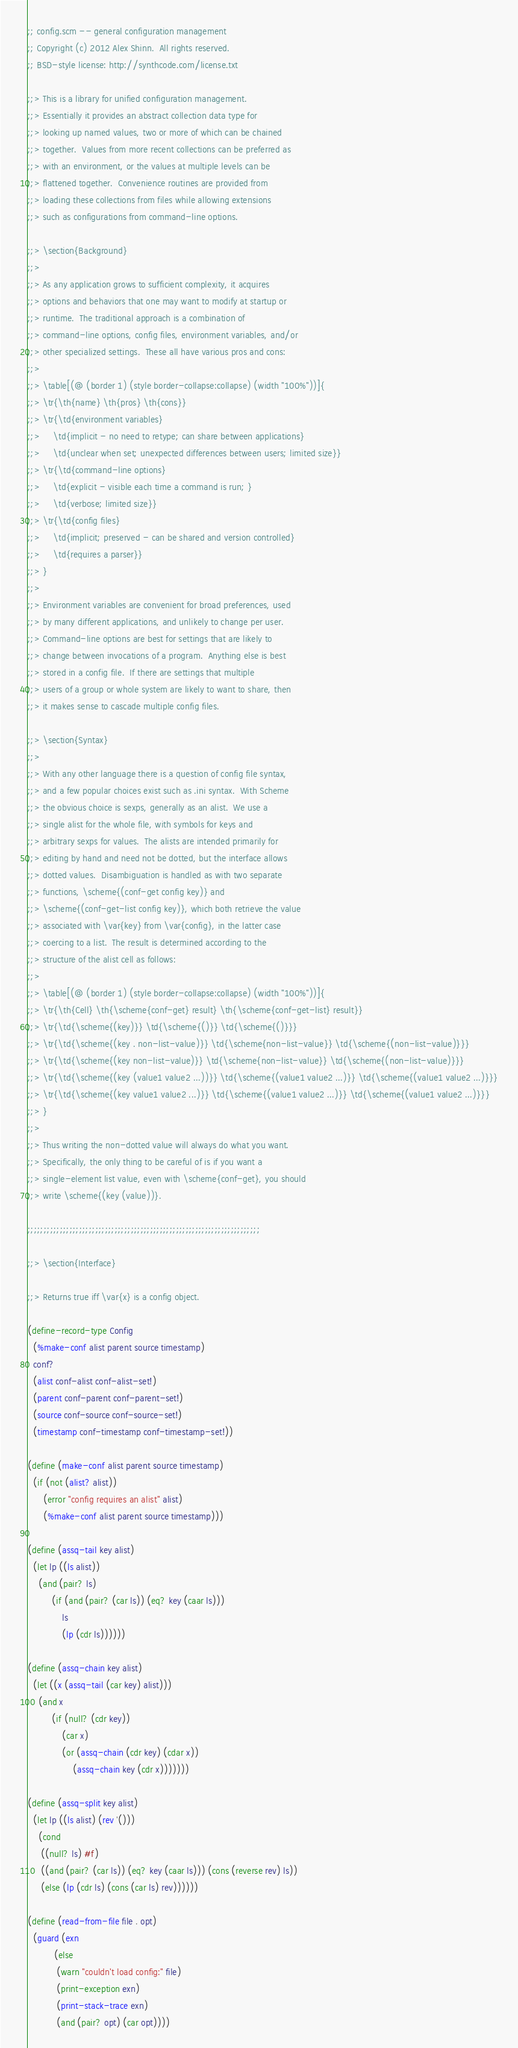Convert code to text. <code><loc_0><loc_0><loc_500><loc_500><_Scheme_>;; config.scm -- general configuration management
;; Copyright (c) 2012 Alex Shinn.  All rights reserved.
;; BSD-style license: http://synthcode.com/license.txt

;;> This is a library for unified configuration management.
;;> Essentially it provides an abstract collection data type for
;;> looking up named values, two or more of which can be chained
;;> together.  Values from more recent collections can be preferred as
;;> with an environment, or the values at multiple levels can be
;;> flattened together.  Convenience routines are provided from
;;> loading these collections from files while allowing extensions
;;> such as configurations from command-line options.

;;> \section{Background}
;;>
;;> As any application grows to sufficient complexity, it acquires
;;> options and behaviors that one may want to modify at startup or
;;> runtime.  The traditional approach is a combination of
;;> command-line options, config files, environment variables, and/or
;;> other specialized settings.  These all have various pros and cons:
;;>
;;> \table[(@ (border 1) (style border-collapse:collapse) (width "100%"))]{
;;> \tr{\th{name} \th{pros} \th{cons}}
;;> \tr{\td{environment variables}
;;>     \td{implicit - no need to retype; can share between applications}
;;>     \td{unclear when set; unexpected differences between users; limited size}}
;;> \tr{\td{command-line options}
;;>     \td{explicit - visible each time a command is run; }
;;>     \td{verbose; limited size}}
;;> \tr{\td{config files}
;;>     \td{implicit; preserved - can be shared and version controlled}
;;>     \td{requires a parser}}
;;> }
;;>
;;> Environment variables are convenient for broad preferences, used
;;> by many different applications, and unlikely to change per user.
;;> Command-line options are best for settings that are likely to
;;> change between invocations of a program.  Anything else is best
;;> stored in a config file.  If there are settings that multiple
;;> users of a group or whole system are likely to want to share, then
;;> it makes sense to cascade multiple config files.

;;> \section{Syntax}
;;>
;;> With any other language there is a question of config file syntax,
;;> and a few popular choices exist such as .ini syntax.  With Scheme
;;> the obvious choice is sexps, generally as an alist.  We use a
;;> single alist for the whole file, with symbols for keys and
;;> arbitrary sexps for values.  The alists are intended primarily for
;;> editing by hand and need not be dotted, but the interface allows
;;> dotted values.  Disambiguation is handled as with two separate
;;> functions, \scheme{(conf-get config key)} and
;;> \scheme{(conf-get-list config key)}, which both retrieve the value
;;> associated with \var{key} from \var{config}, in the latter case
;;> coercing to a list.  The result is determined according to the
;;> structure of the alist cell as follows:
;;>
;;> \table[(@ (border 1) (style border-collapse:collapse) (width "100%"))]{
;;> \tr{\th{Cell} \th{\scheme{conf-get} result} \th{\scheme{conf-get-list} result}}
;;> \tr{\td{\scheme{(key)}} \td{\scheme{()}} \td{\scheme{()}}}
;;> \tr{\td{\scheme{(key . non-list-value)}} \td{\scheme{non-list-value}} \td{\scheme{(non-list-value)}}}
;;> \tr{\td{\scheme{(key non-list-value)}} \td{\scheme{non-list-value}} \td{\scheme{(non-list-value)}}}
;;> \tr{\td{\scheme{(key (value1 value2 ...))}} \td{\scheme{(value1 value2 ...)}} \td{\scheme{(value1 value2 ...)}}}
;;> \tr{\td{\scheme{(key value1 value2 ...)}} \td{\scheme{(value1 value2 ...)}} \td{\scheme{(value1 value2 ...)}}}
;;> }
;;>
;;> Thus writing the non-dotted value will always do what you want.
;;> Specifically, the only thing to be careful of is if you want a
;;> single-element list value, even with \scheme{conf-get}, you should
;;> write \scheme{(key (value))}.

;;;;;;;;;;;;;;;;;;;;;;;;;;;;;;;;;;;;;;;;;;;;;;;;;;;;;;;;;;;;;;;;;;;;;;;;

;;> \section{Interface}

;;> Returns true iff \var{x} is a config object.

(define-record-type Config
  (%make-conf alist parent source timestamp)
  conf?
  (alist conf-alist conf-alist-set!)
  (parent conf-parent conf-parent-set!)
  (source conf-source conf-source-set!)
  (timestamp conf-timestamp conf-timestamp-set!))

(define (make-conf alist parent source timestamp)
  (if (not (alist? alist))
      (error "config requires an alist" alist)
      (%make-conf alist parent source timestamp)))

(define (assq-tail key alist)
  (let lp ((ls alist))
    (and (pair? ls)
         (if (and (pair? (car ls)) (eq? key (caar ls)))
             ls
             (lp (cdr ls))))))

(define (assq-chain key alist)
  (let ((x (assq-tail (car key) alist)))
    (and x
         (if (null? (cdr key))
             (car x)
             (or (assq-chain (cdr key) (cdar x))
                 (assq-chain key (cdr x)))))))

(define (assq-split key alist)
  (let lp ((ls alist) (rev '()))
    (cond
     ((null? ls) #f)
     ((and (pair? (car ls)) (eq? key (caar ls))) (cons (reverse rev) ls))
     (else (lp (cdr ls) (cons (car ls) rev))))))

(define (read-from-file file . opt)
  (guard (exn
          (else
           (warn "couldn't load config:" file)
           (print-exception exn)
           (print-stack-trace exn)
           (and (pair? opt) (car opt))))</code> 